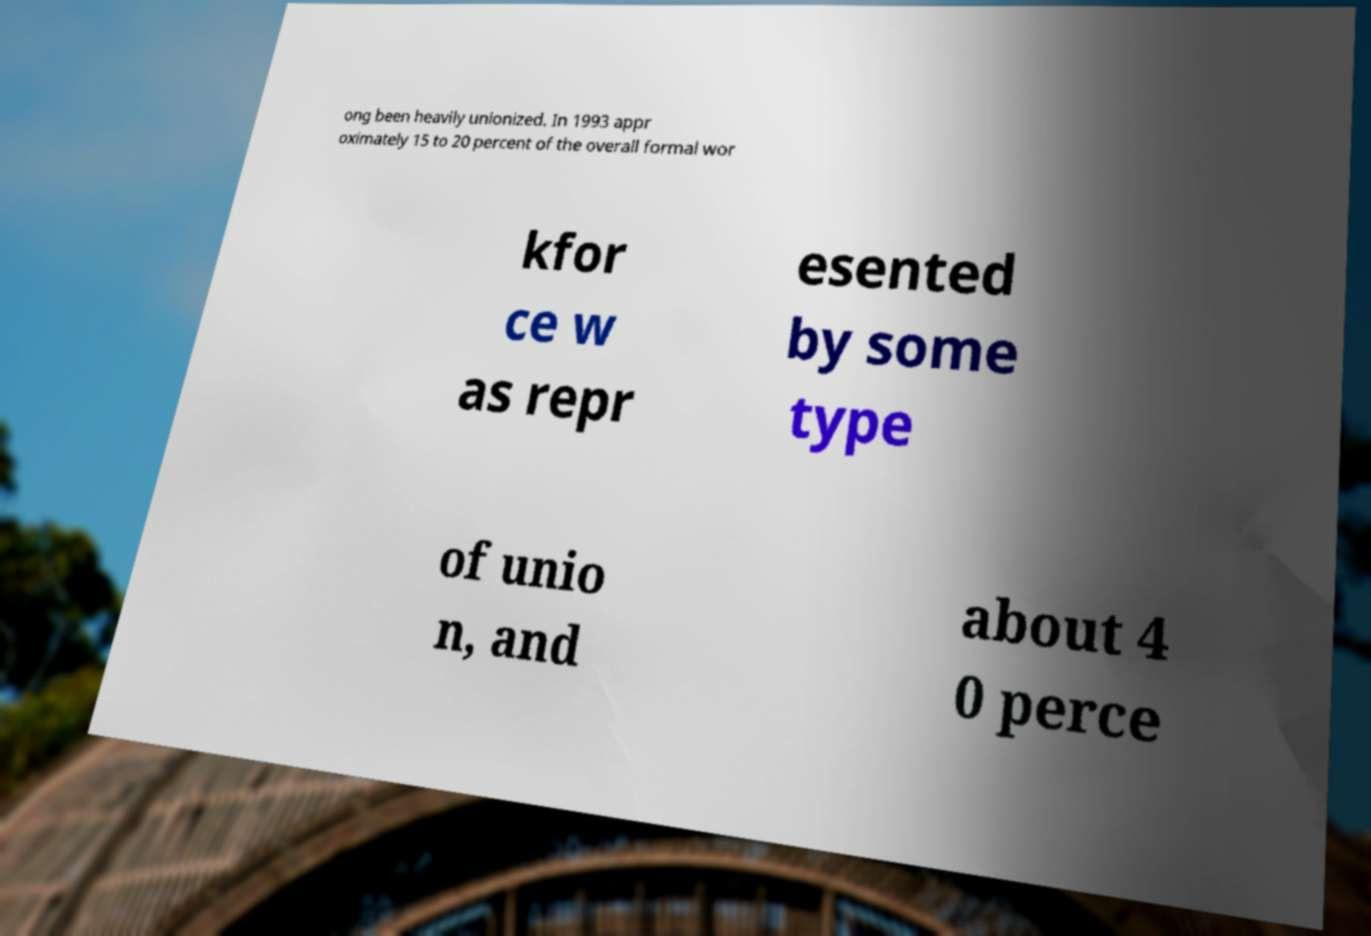I need the written content from this picture converted into text. Can you do that? ong been heavily unionized. In 1993 appr oximately 15 to 20 percent of the overall formal wor kfor ce w as repr esented by some type of unio n, and about 4 0 perce 